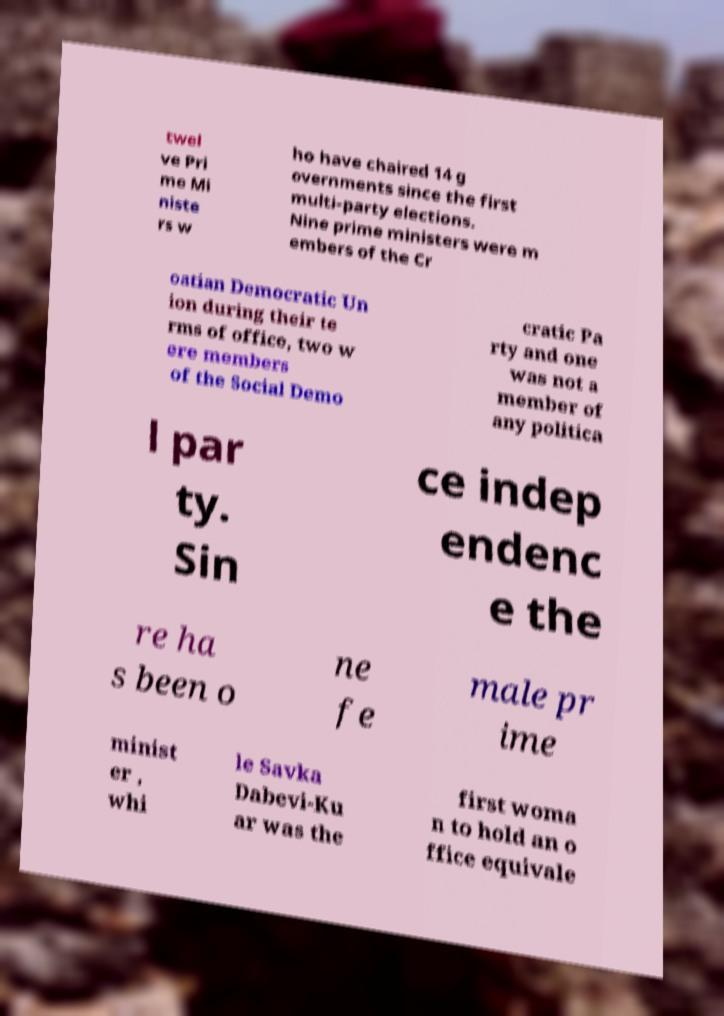What messages or text are displayed in this image? I need them in a readable, typed format. twel ve Pri me Mi niste rs w ho have chaired 14 g overnments since the first multi-party elections. Nine prime ministers were m embers of the Cr oatian Democratic Un ion during their te rms of office, two w ere members of the Social Demo cratic Pa rty and one was not a member of any politica l par ty. Sin ce indep endenc e the re ha s been o ne fe male pr ime minist er , whi le Savka Dabevi-Ku ar was the first woma n to hold an o ffice equivale 